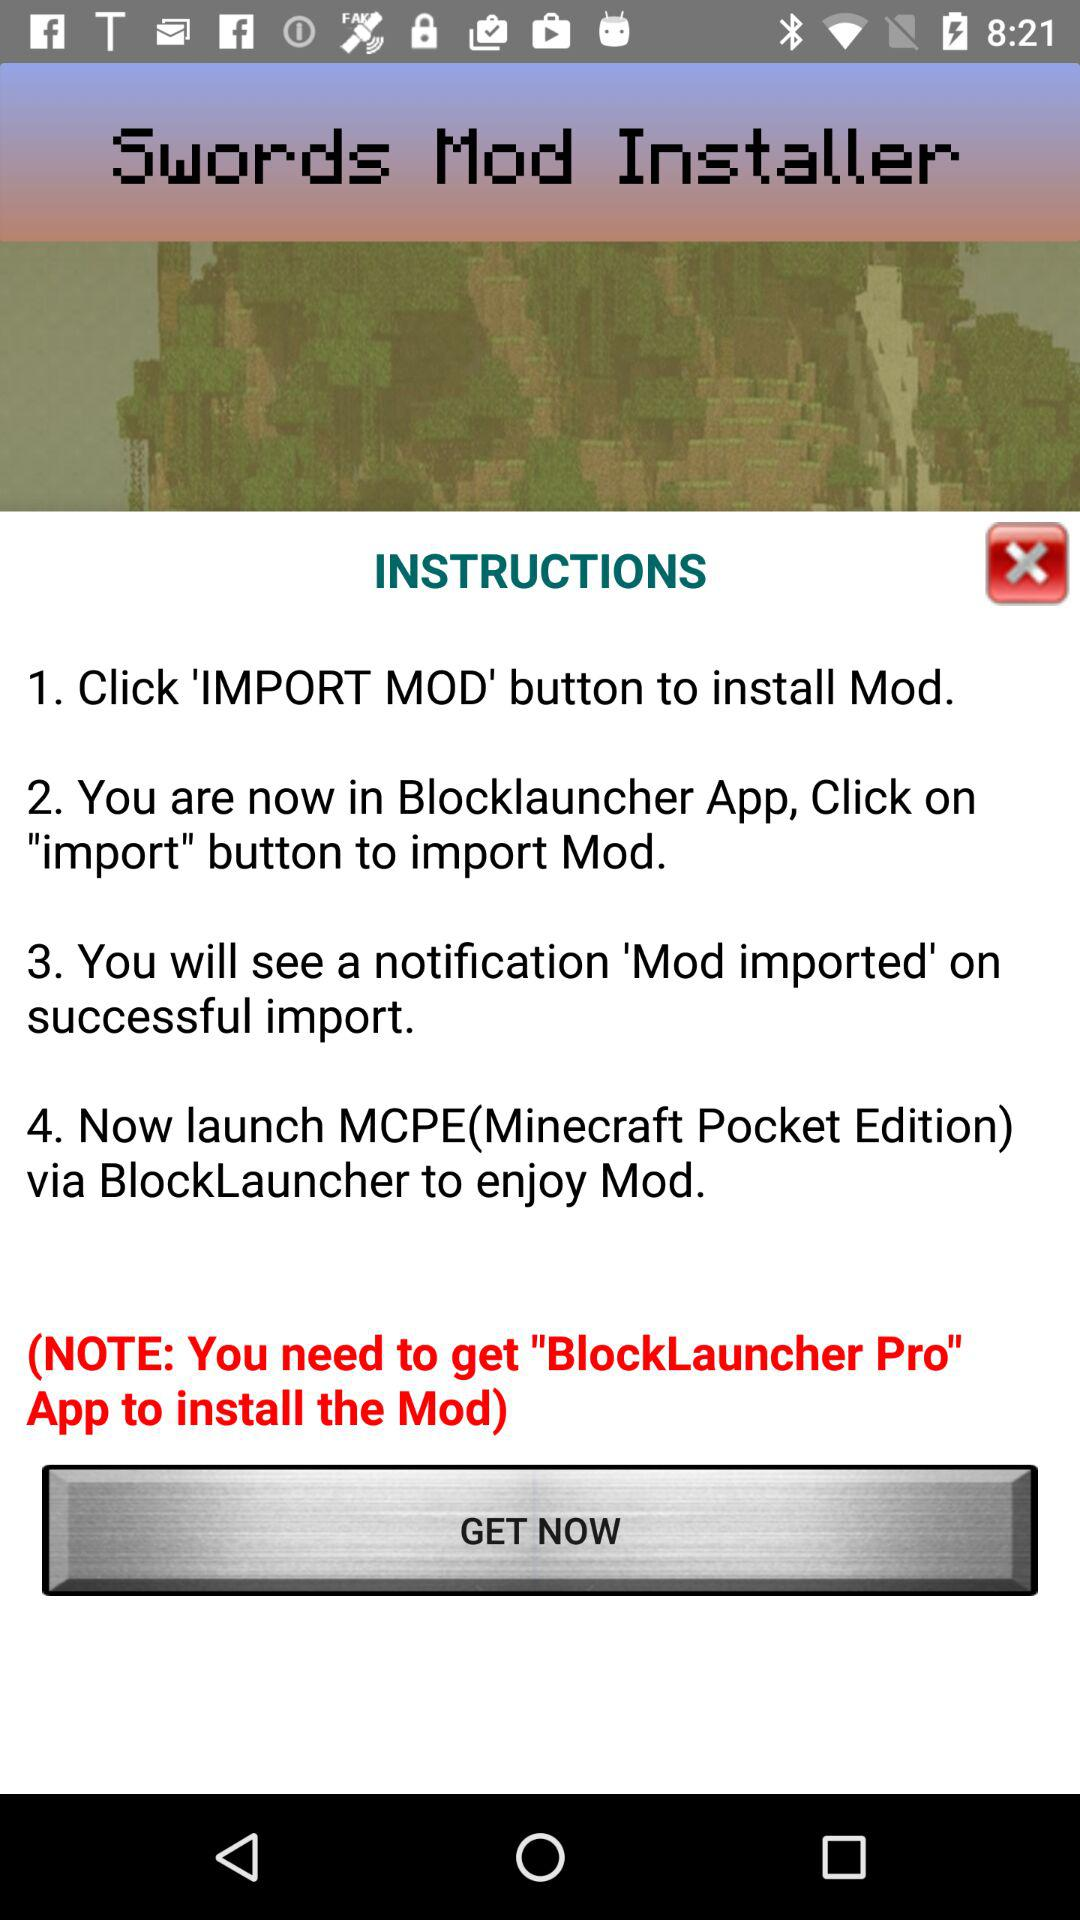What is the full form of MCPE? The full form is "Minecraft Pocket Edition". 